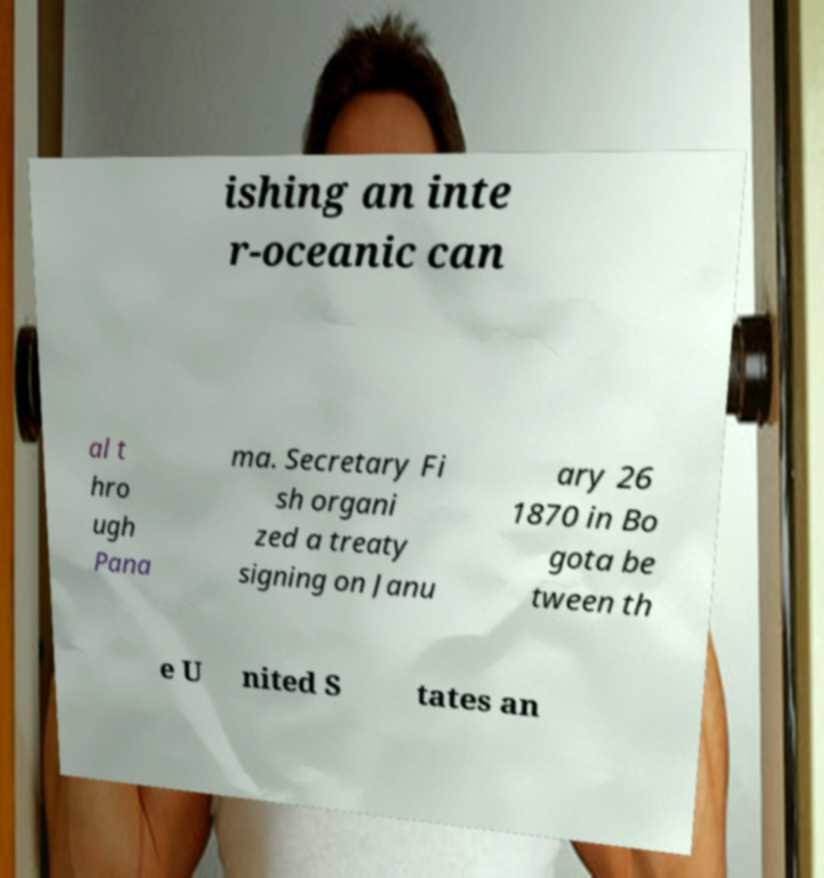Could you extract and type out the text from this image? ishing an inte r-oceanic can al t hro ugh Pana ma. Secretary Fi sh organi zed a treaty signing on Janu ary 26 1870 in Bo gota be tween th e U nited S tates an 